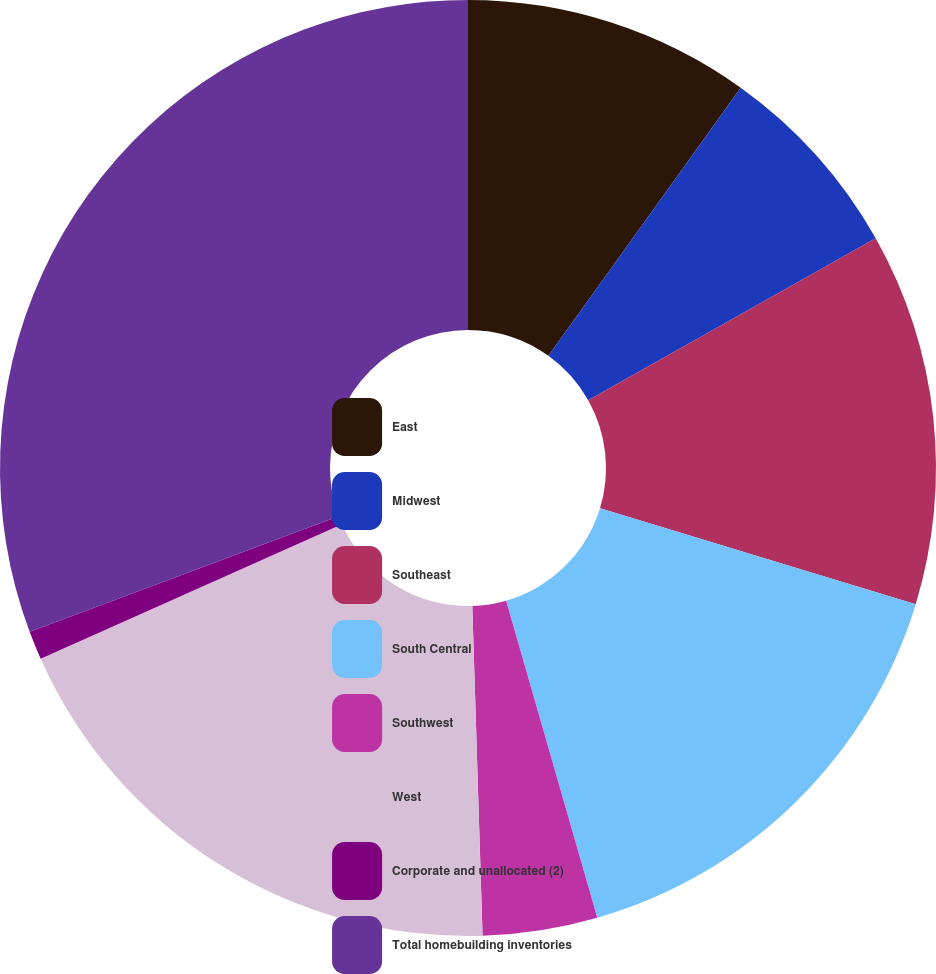Convert chart to OTSL. <chart><loc_0><loc_0><loc_500><loc_500><pie_chart><fcel>East<fcel>Midwest<fcel>Southeast<fcel>South Central<fcel>Southwest<fcel>West<fcel>Corporate and unallocated (2)<fcel>Total homebuilding inventories<nl><fcel>9.9%<fcel>6.93%<fcel>12.87%<fcel>15.84%<fcel>3.96%<fcel>18.81%<fcel>0.99%<fcel>30.69%<nl></chart> 